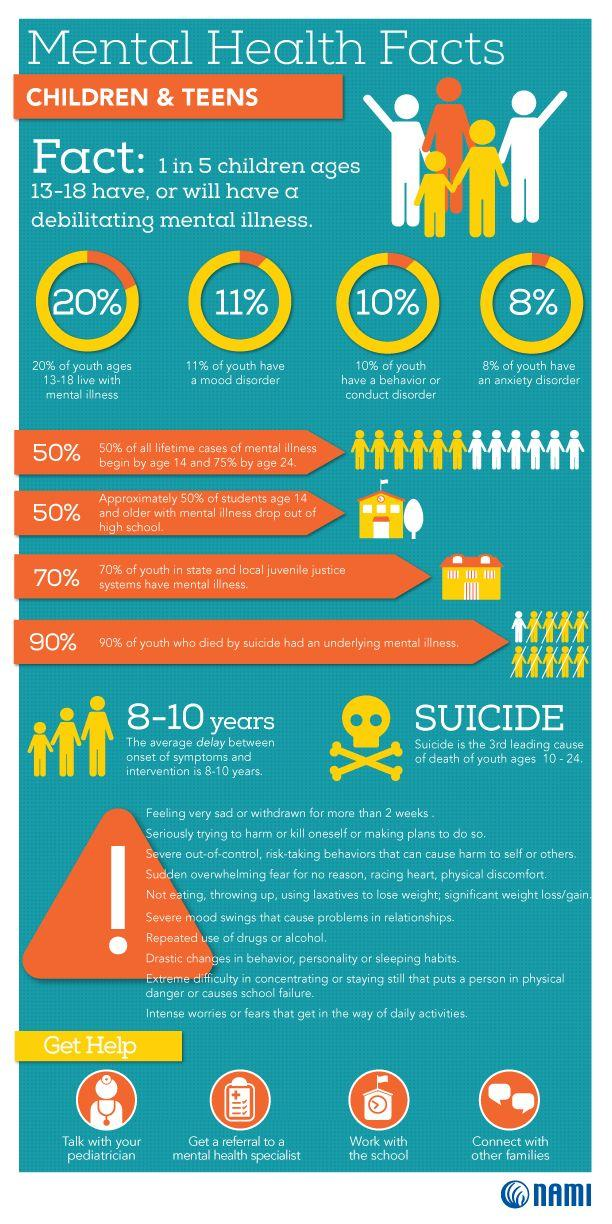Specify some key components in this picture. According to a recent study, 8% of youth are affected by anxiety disorders. According to recent studies, it has been found that only 10% of youth do not have a problem with conduct disorder. According to recent studies, approximately 11% of youth are affected by mood disorders. The average delay between the onset of symptoms and intervention in mental illness is approximately 8-10 years. 